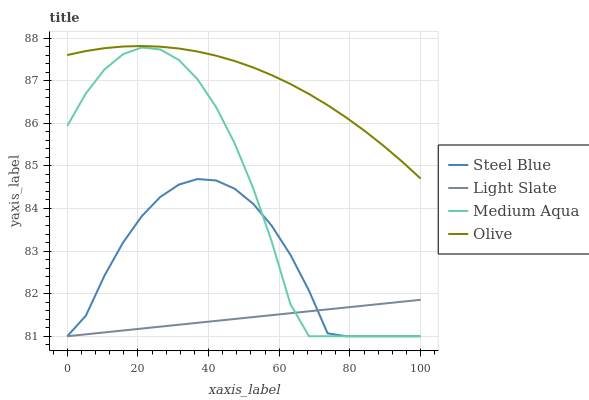Does Light Slate have the minimum area under the curve?
Answer yes or no. Yes. Does Olive have the maximum area under the curve?
Answer yes or no. Yes. Does Medium Aqua have the minimum area under the curve?
Answer yes or no. No. Does Medium Aqua have the maximum area under the curve?
Answer yes or no. No. Is Light Slate the smoothest?
Answer yes or no. Yes. Is Medium Aqua the roughest?
Answer yes or no. Yes. Is Olive the smoothest?
Answer yes or no. No. Is Olive the roughest?
Answer yes or no. No. Does Light Slate have the lowest value?
Answer yes or no. Yes. Does Olive have the lowest value?
Answer yes or no. No. Does Olive have the highest value?
Answer yes or no. Yes. Does Medium Aqua have the highest value?
Answer yes or no. No. Is Light Slate less than Olive?
Answer yes or no. Yes. Is Olive greater than Light Slate?
Answer yes or no. Yes. Does Light Slate intersect Medium Aqua?
Answer yes or no. Yes. Is Light Slate less than Medium Aqua?
Answer yes or no. No. Is Light Slate greater than Medium Aqua?
Answer yes or no. No. Does Light Slate intersect Olive?
Answer yes or no. No. 